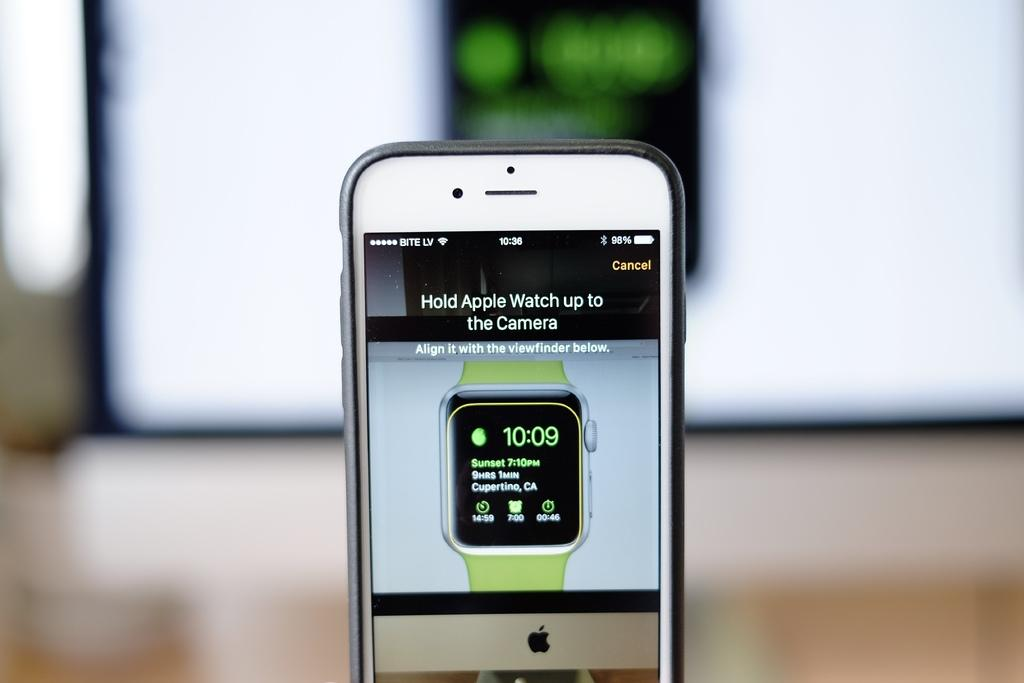<image>
Share a concise interpretation of the image provided. An apple iPhone telling the user to hold their apple watch up to the camera. 